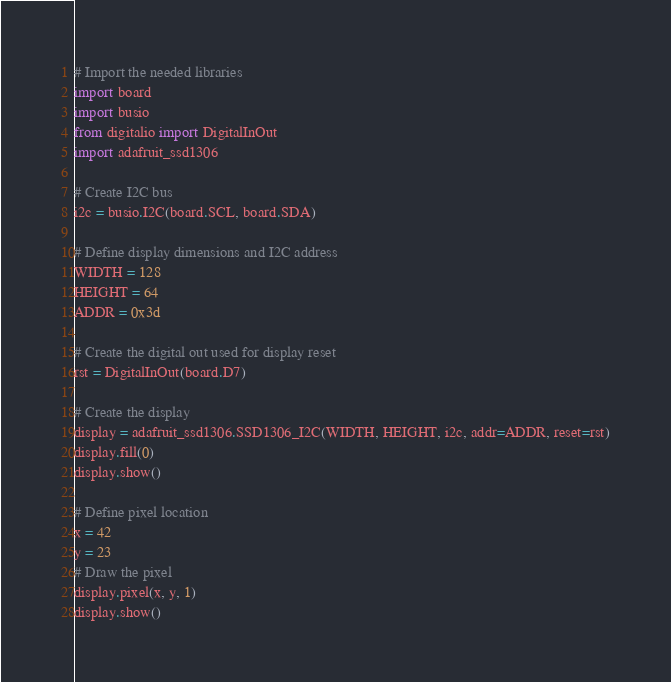<code> <loc_0><loc_0><loc_500><loc_500><_Python_># Import the needed libraries
import board
import busio
from digitalio import DigitalInOut
import adafruit_ssd1306

# Create I2C bus
i2c = busio.I2C(board.SCL, board.SDA)

# Define display dimensions and I2C address
WIDTH = 128
HEIGHT = 64
ADDR = 0x3d

# Create the digital out used for display reset
rst = DigitalInOut(board.D7)

# Create the display
display = adafruit_ssd1306.SSD1306_I2C(WIDTH, HEIGHT, i2c, addr=ADDR, reset=rst)
display.fill(0)
display.show()

# Define pixel location
x = 42
y = 23
# Draw the pixel
display.pixel(x, y, 1)
display.show()
</code> 